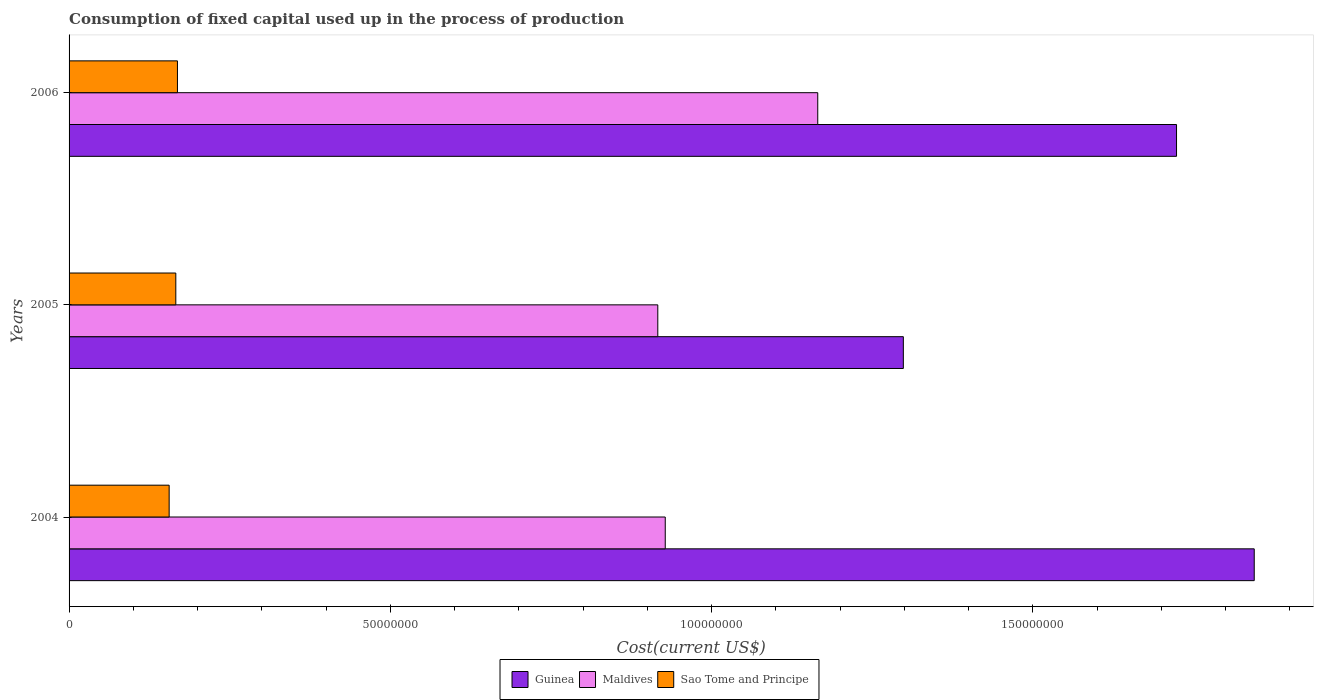How many different coloured bars are there?
Offer a very short reply. 3. How many groups of bars are there?
Provide a short and direct response. 3. How many bars are there on the 3rd tick from the top?
Offer a terse response. 3. How many bars are there on the 3rd tick from the bottom?
Your response must be concise. 3. What is the label of the 1st group of bars from the top?
Your answer should be very brief. 2006. What is the amount consumed in the process of production in Maldives in 2004?
Provide a short and direct response. 9.28e+07. Across all years, what is the maximum amount consumed in the process of production in Sao Tome and Principe?
Provide a short and direct response. 1.69e+07. Across all years, what is the minimum amount consumed in the process of production in Guinea?
Offer a very short reply. 1.30e+08. What is the total amount consumed in the process of production in Maldives in the graph?
Your response must be concise. 3.01e+08. What is the difference between the amount consumed in the process of production in Maldives in 2004 and that in 2006?
Keep it short and to the point. -2.37e+07. What is the difference between the amount consumed in the process of production in Guinea in 2006 and the amount consumed in the process of production in Sao Tome and Principe in 2005?
Make the answer very short. 1.56e+08. What is the average amount consumed in the process of production in Sao Tome and Principe per year?
Give a very brief answer. 1.64e+07. In the year 2004, what is the difference between the amount consumed in the process of production in Sao Tome and Principe and amount consumed in the process of production in Maldives?
Your answer should be very brief. -7.72e+07. In how many years, is the amount consumed in the process of production in Maldives greater than 140000000 US$?
Keep it short and to the point. 0. What is the ratio of the amount consumed in the process of production in Guinea in 2004 to that in 2006?
Your response must be concise. 1.07. Is the difference between the amount consumed in the process of production in Sao Tome and Principe in 2005 and 2006 greater than the difference between the amount consumed in the process of production in Maldives in 2005 and 2006?
Offer a terse response. Yes. What is the difference between the highest and the second highest amount consumed in the process of production in Maldives?
Offer a terse response. 2.37e+07. What is the difference between the highest and the lowest amount consumed in the process of production in Guinea?
Your answer should be compact. 5.46e+07. In how many years, is the amount consumed in the process of production in Guinea greater than the average amount consumed in the process of production in Guinea taken over all years?
Make the answer very short. 2. What does the 2nd bar from the top in 2005 represents?
Offer a very short reply. Maldives. What does the 3rd bar from the bottom in 2006 represents?
Make the answer very short. Sao Tome and Principe. Is it the case that in every year, the sum of the amount consumed in the process of production in Guinea and amount consumed in the process of production in Sao Tome and Principe is greater than the amount consumed in the process of production in Maldives?
Your response must be concise. Yes. How many bars are there?
Your answer should be very brief. 9. How many years are there in the graph?
Offer a very short reply. 3. What is the difference between two consecutive major ticks on the X-axis?
Offer a terse response. 5.00e+07. Are the values on the major ticks of X-axis written in scientific E-notation?
Keep it short and to the point. No. Does the graph contain grids?
Your answer should be compact. No. Where does the legend appear in the graph?
Offer a very short reply. Bottom center. How many legend labels are there?
Offer a terse response. 3. What is the title of the graph?
Your response must be concise. Consumption of fixed capital used up in the process of production. What is the label or title of the X-axis?
Offer a terse response. Cost(current US$). What is the label or title of the Y-axis?
Provide a short and direct response. Years. What is the Cost(current US$) of Guinea in 2004?
Give a very brief answer. 1.84e+08. What is the Cost(current US$) in Maldives in 2004?
Provide a succinct answer. 9.28e+07. What is the Cost(current US$) in Sao Tome and Principe in 2004?
Ensure brevity in your answer.  1.56e+07. What is the Cost(current US$) of Guinea in 2005?
Provide a succinct answer. 1.30e+08. What is the Cost(current US$) in Maldives in 2005?
Offer a terse response. 9.16e+07. What is the Cost(current US$) of Sao Tome and Principe in 2005?
Give a very brief answer. 1.66e+07. What is the Cost(current US$) of Guinea in 2006?
Your answer should be compact. 1.72e+08. What is the Cost(current US$) in Maldives in 2006?
Provide a short and direct response. 1.17e+08. What is the Cost(current US$) in Sao Tome and Principe in 2006?
Offer a terse response. 1.69e+07. Across all years, what is the maximum Cost(current US$) in Guinea?
Provide a succinct answer. 1.84e+08. Across all years, what is the maximum Cost(current US$) of Maldives?
Your response must be concise. 1.17e+08. Across all years, what is the maximum Cost(current US$) in Sao Tome and Principe?
Make the answer very short. 1.69e+07. Across all years, what is the minimum Cost(current US$) of Guinea?
Offer a very short reply. 1.30e+08. Across all years, what is the minimum Cost(current US$) in Maldives?
Ensure brevity in your answer.  9.16e+07. Across all years, what is the minimum Cost(current US$) in Sao Tome and Principe?
Your answer should be very brief. 1.56e+07. What is the total Cost(current US$) of Guinea in the graph?
Give a very brief answer. 4.87e+08. What is the total Cost(current US$) of Maldives in the graph?
Your answer should be very brief. 3.01e+08. What is the total Cost(current US$) of Sao Tome and Principe in the graph?
Provide a short and direct response. 4.91e+07. What is the difference between the Cost(current US$) in Guinea in 2004 and that in 2005?
Make the answer very short. 5.46e+07. What is the difference between the Cost(current US$) in Maldives in 2004 and that in 2005?
Your answer should be compact. 1.16e+06. What is the difference between the Cost(current US$) in Sao Tome and Principe in 2004 and that in 2005?
Provide a succinct answer. -1.04e+06. What is the difference between the Cost(current US$) in Guinea in 2004 and that in 2006?
Make the answer very short. 1.21e+07. What is the difference between the Cost(current US$) of Maldives in 2004 and that in 2006?
Give a very brief answer. -2.37e+07. What is the difference between the Cost(current US$) in Sao Tome and Principe in 2004 and that in 2006?
Your answer should be compact. -1.29e+06. What is the difference between the Cost(current US$) of Guinea in 2005 and that in 2006?
Your answer should be compact. -4.25e+07. What is the difference between the Cost(current US$) of Maldives in 2005 and that in 2006?
Make the answer very short. -2.49e+07. What is the difference between the Cost(current US$) in Sao Tome and Principe in 2005 and that in 2006?
Offer a very short reply. -2.56e+05. What is the difference between the Cost(current US$) in Guinea in 2004 and the Cost(current US$) in Maldives in 2005?
Offer a terse response. 9.28e+07. What is the difference between the Cost(current US$) in Guinea in 2004 and the Cost(current US$) in Sao Tome and Principe in 2005?
Ensure brevity in your answer.  1.68e+08. What is the difference between the Cost(current US$) in Maldives in 2004 and the Cost(current US$) in Sao Tome and Principe in 2005?
Keep it short and to the point. 7.62e+07. What is the difference between the Cost(current US$) in Guinea in 2004 and the Cost(current US$) in Maldives in 2006?
Give a very brief answer. 6.79e+07. What is the difference between the Cost(current US$) of Guinea in 2004 and the Cost(current US$) of Sao Tome and Principe in 2006?
Make the answer very short. 1.68e+08. What is the difference between the Cost(current US$) of Maldives in 2004 and the Cost(current US$) of Sao Tome and Principe in 2006?
Make the answer very short. 7.59e+07. What is the difference between the Cost(current US$) in Guinea in 2005 and the Cost(current US$) in Maldives in 2006?
Provide a succinct answer. 1.33e+07. What is the difference between the Cost(current US$) of Guinea in 2005 and the Cost(current US$) of Sao Tome and Principe in 2006?
Ensure brevity in your answer.  1.13e+08. What is the difference between the Cost(current US$) of Maldives in 2005 and the Cost(current US$) of Sao Tome and Principe in 2006?
Offer a very short reply. 7.48e+07. What is the average Cost(current US$) in Guinea per year?
Your response must be concise. 1.62e+08. What is the average Cost(current US$) of Maldives per year?
Provide a short and direct response. 1.00e+08. What is the average Cost(current US$) of Sao Tome and Principe per year?
Provide a succinct answer. 1.64e+07. In the year 2004, what is the difference between the Cost(current US$) of Guinea and Cost(current US$) of Maldives?
Give a very brief answer. 9.17e+07. In the year 2004, what is the difference between the Cost(current US$) in Guinea and Cost(current US$) in Sao Tome and Principe?
Provide a short and direct response. 1.69e+08. In the year 2004, what is the difference between the Cost(current US$) in Maldives and Cost(current US$) in Sao Tome and Principe?
Give a very brief answer. 7.72e+07. In the year 2005, what is the difference between the Cost(current US$) of Guinea and Cost(current US$) of Maldives?
Your answer should be compact. 3.82e+07. In the year 2005, what is the difference between the Cost(current US$) of Guinea and Cost(current US$) of Sao Tome and Principe?
Your response must be concise. 1.13e+08. In the year 2005, what is the difference between the Cost(current US$) of Maldives and Cost(current US$) of Sao Tome and Principe?
Offer a terse response. 7.50e+07. In the year 2006, what is the difference between the Cost(current US$) of Guinea and Cost(current US$) of Maldives?
Provide a short and direct response. 5.58e+07. In the year 2006, what is the difference between the Cost(current US$) in Guinea and Cost(current US$) in Sao Tome and Principe?
Give a very brief answer. 1.55e+08. In the year 2006, what is the difference between the Cost(current US$) of Maldives and Cost(current US$) of Sao Tome and Principe?
Provide a short and direct response. 9.96e+07. What is the ratio of the Cost(current US$) of Guinea in 2004 to that in 2005?
Keep it short and to the point. 1.42. What is the ratio of the Cost(current US$) of Maldives in 2004 to that in 2005?
Offer a terse response. 1.01. What is the ratio of the Cost(current US$) of Sao Tome and Principe in 2004 to that in 2005?
Offer a very short reply. 0.94. What is the ratio of the Cost(current US$) of Guinea in 2004 to that in 2006?
Provide a short and direct response. 1.07. What is the ratio of the Cost(current US$) of Maldives in 2004 to that in 2006?
Offer a terse response. 0.8. What is the ratio of the Cost(current US$) of Sao Tome and Principe in 2004 to that in 2006?
Give a very brief answer. 0.92. What is the ratio of the Cost(current US$) of Guinea in 2005 to that in 2006?
Provide a succinct answer. 0.75. What is the ratio of the Cost(current US$) in Maldives in 2005 to that in 2006?
Offer a terse response. 0.79. What is the difference between the highest and the second highest Cost(current US$) in Guinea?
Your response must be concise. 1.21e+07. What is the difference between the highest and the second highest Cost(current US$) in Maldives?
Give a very brief answer. 2.37e+07. What is the difference between the highest and the second highest Cost(current US$) of Sao Tome and Principe?
Ensure brevity in your answer.  2.56e+05. What is the difference between the highest and the lowest Cost(current US$) of Guinea?
Offer a very short reply. 5.46e+07. What is the difference between the highest and the lowest Cost(current US$) in Maldives?
Give a very brief answer. 2.49e+07. What is the difference between the highest and the lowest Cost(current US$) in Sao Tome and Principe?
Your answer should be very brief. 1.29e+06. 